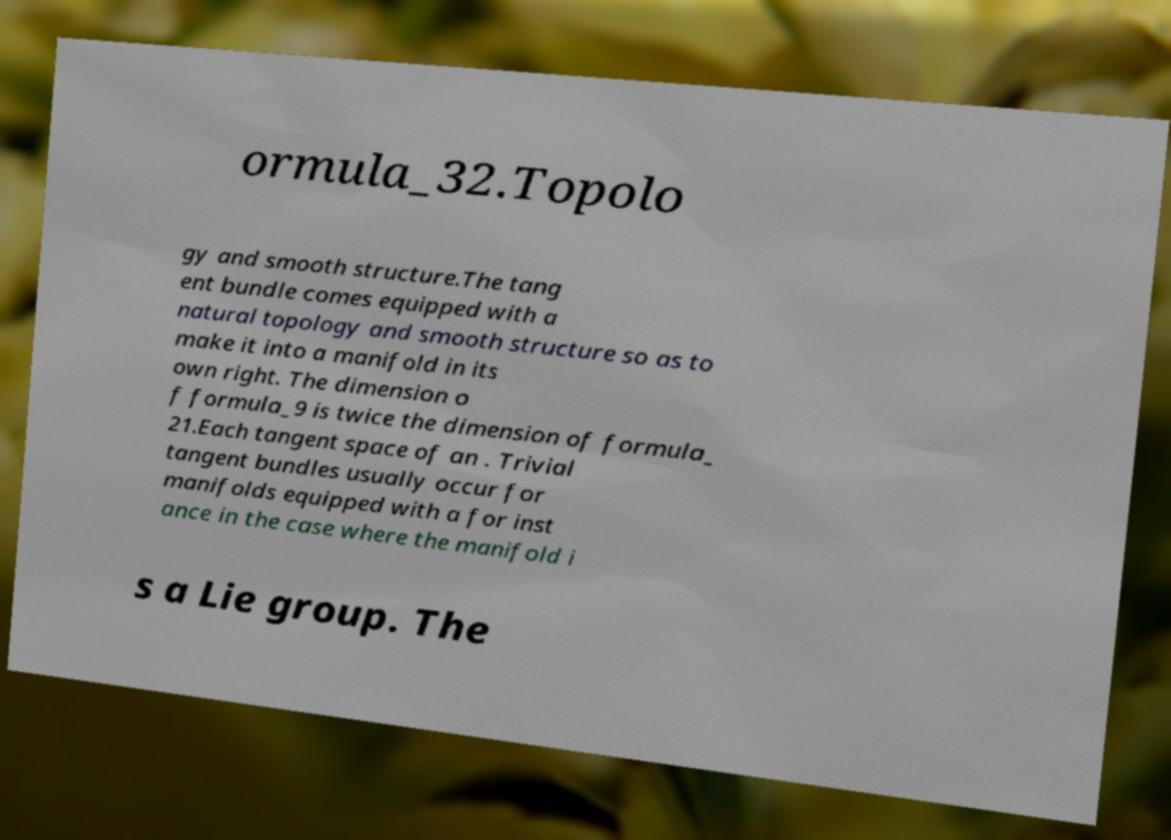Could you extract and type out the text from this image? ormula_32.Topolo gy and smooth structure.The tang ent bundle comes equipped with a natural topology and smooth structure so as to make it into a manifold in its own right. The dimension o f formula_9 is twice the dimension of formula_ 21.Each tangent space of an . Trivial tangent bundles usually occur for manifolds equipped with a for inst ance in the case where the manifold i s a Lie group. The 